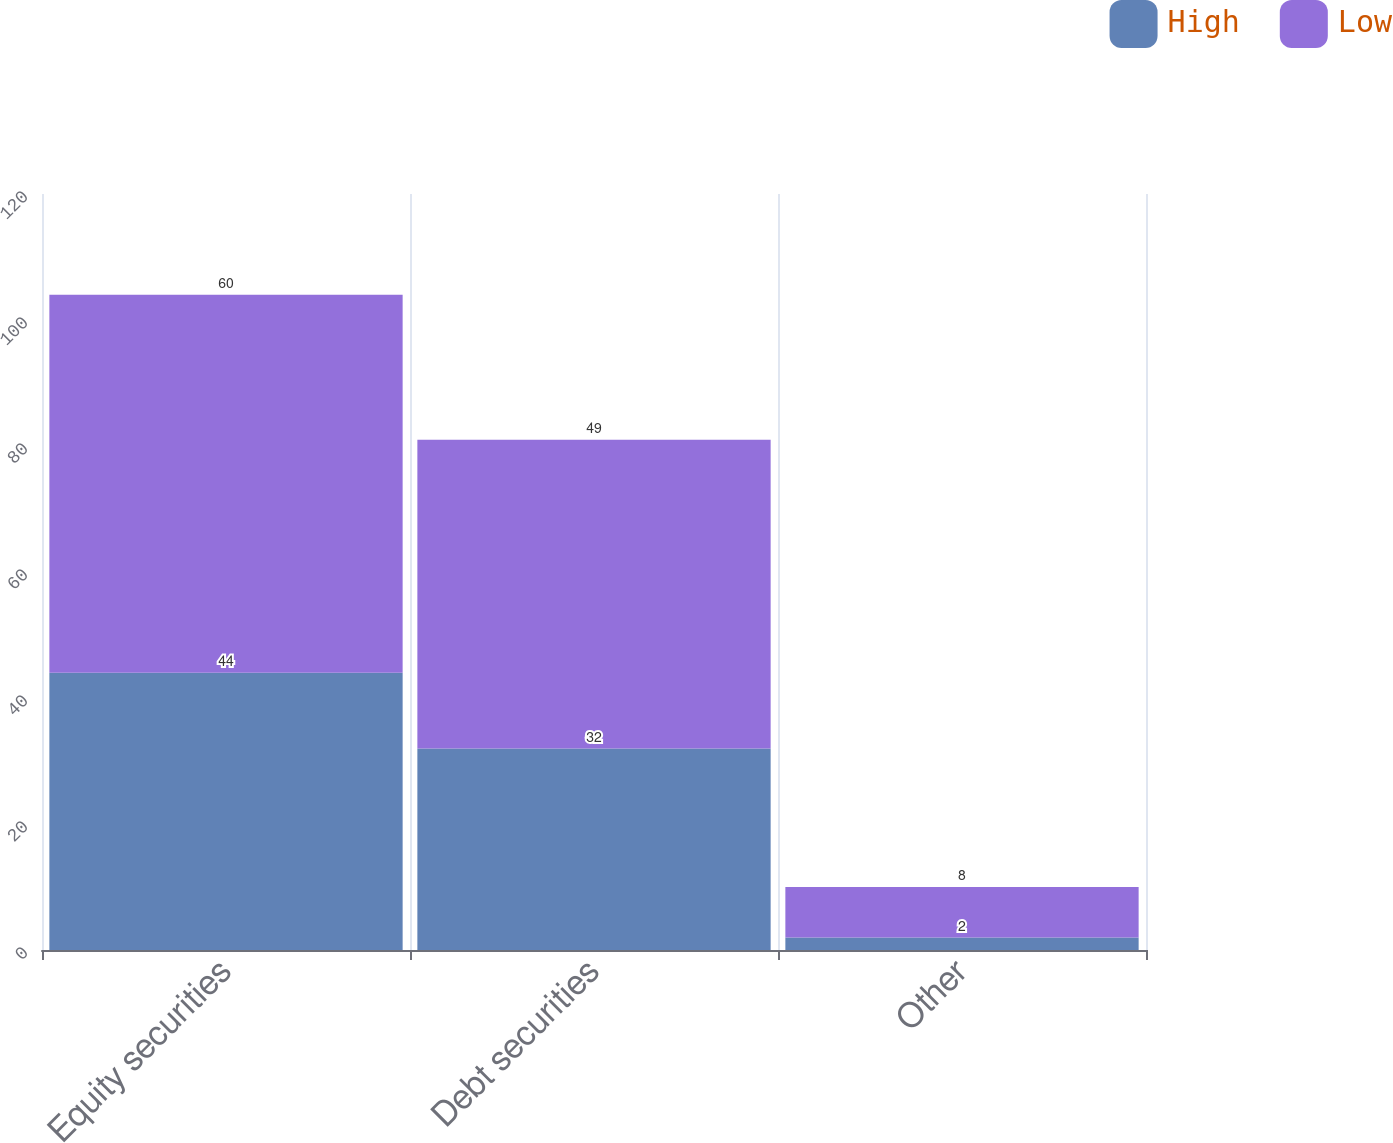Convert chart to OTSL. <chart><loc_0><loc_0><loc_500><loc_500><stacked_bar_chart><ecel><fcel>Equity securities<fcel>Debt securities<fcel>Other<nl><fcel>High<fcel>44<fcel>32<fcel>2<nl><fcel>Low<fcel>60<fcel>49<fcel>8<nl></chart> 